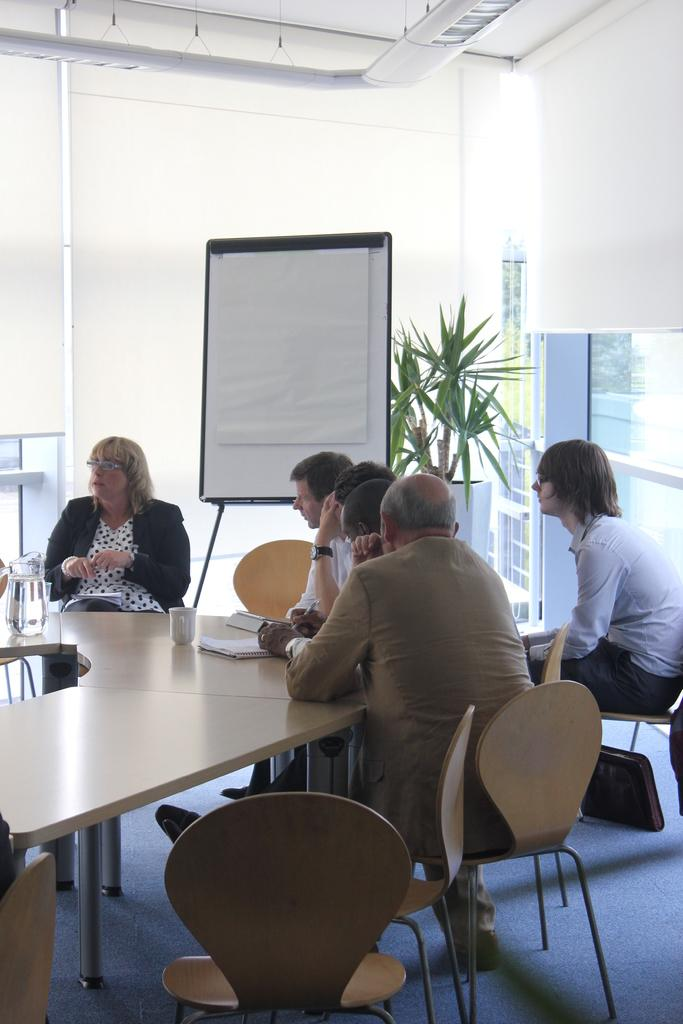What are the persons in the image doing? The persons in the image are sitting on chairs. What objects can be seen on the table in the image? There is a jar, a cup, and a book on the table in the image. What is the purpose of the whiteboard visible in the image? The whiteboard is visible in the image, but its purpose is not explicitly stated. What type of vegetation is present behind the whiteboard? There is a plant behind the whiteboard in the image. What type of rose can be seen growing on the whiteboard in the image? There is no rose present on the whiteboard in the image. What type of song is being sung by the persons sitting on chairs in the image? There is no indication in the image that the persons are singing a song. 